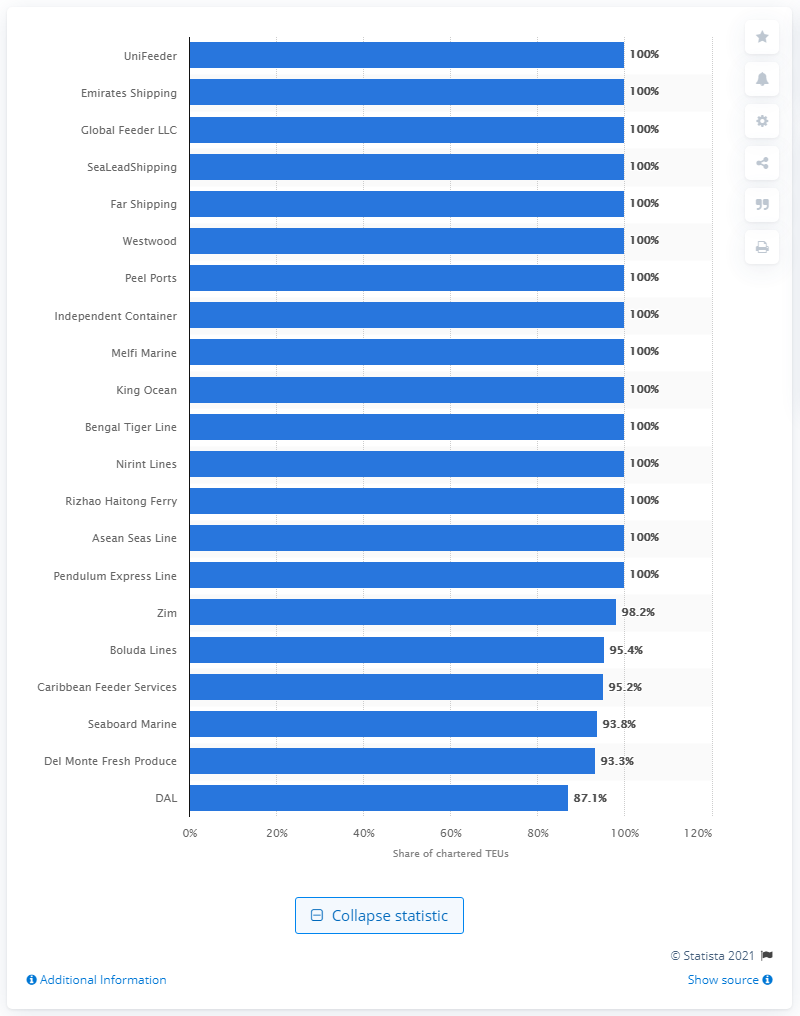Mention a couple of crucial points in this snapshot. Del Monte Fresh Produce chartered 93.8% of the total capacity that was available for charter. 